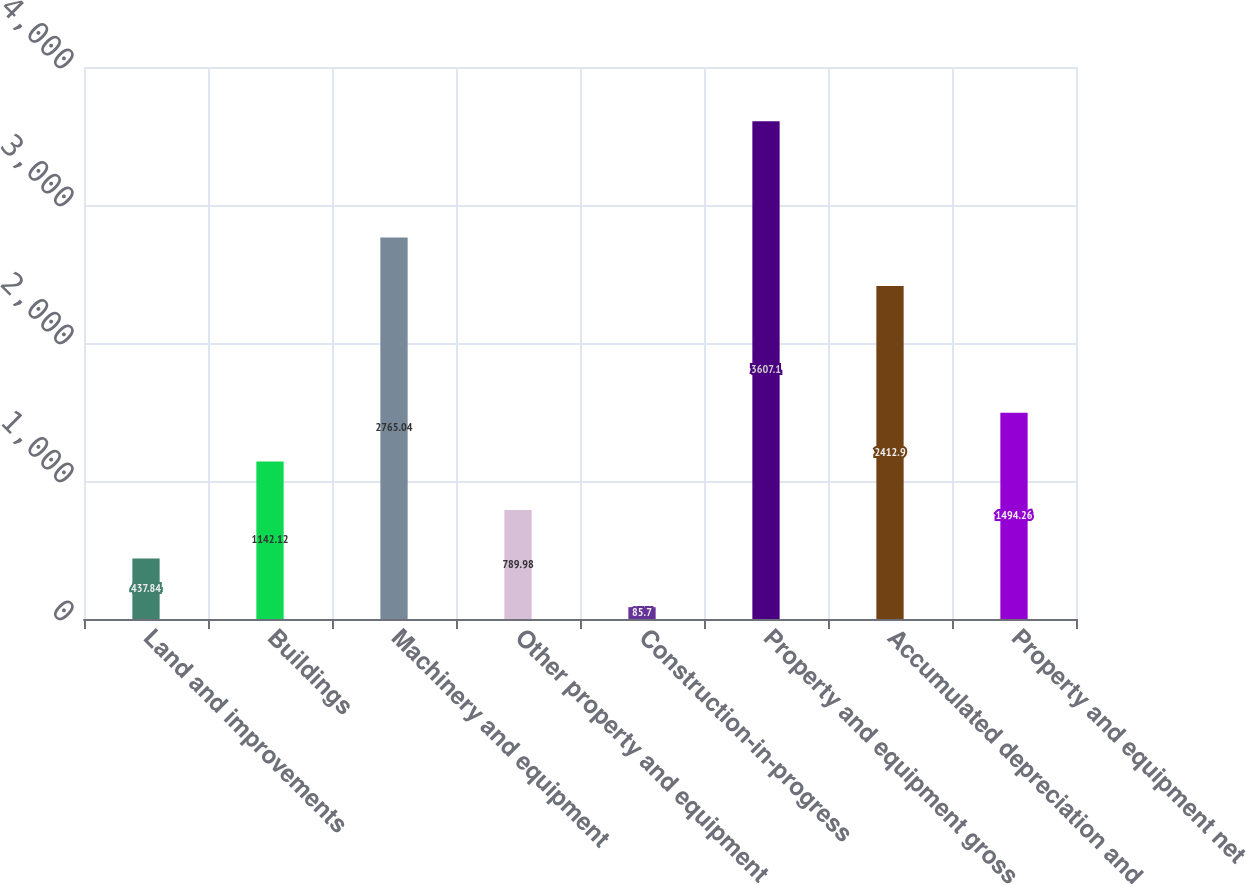Convert chart to OTSL. <chart><loc_0><loc_0><loc_500><loc_500><bar_chart><fcel>Land and improvements<fcel>Buildings<fcel>Machinery and equipment<fcel>Other property and equipment<fcel>Construction-in-progress<fcel>Property and equipment gross<fcel>Accumulated depreciation and<fcel>Property and equipment net<nl><fcel>437.84<fcel>1142.12<fcel>2765.04<fcel>789.98<fcel>85.7<fcel>3607.1<fcel>2412.9<fcel>1494.26<nl></chart> 